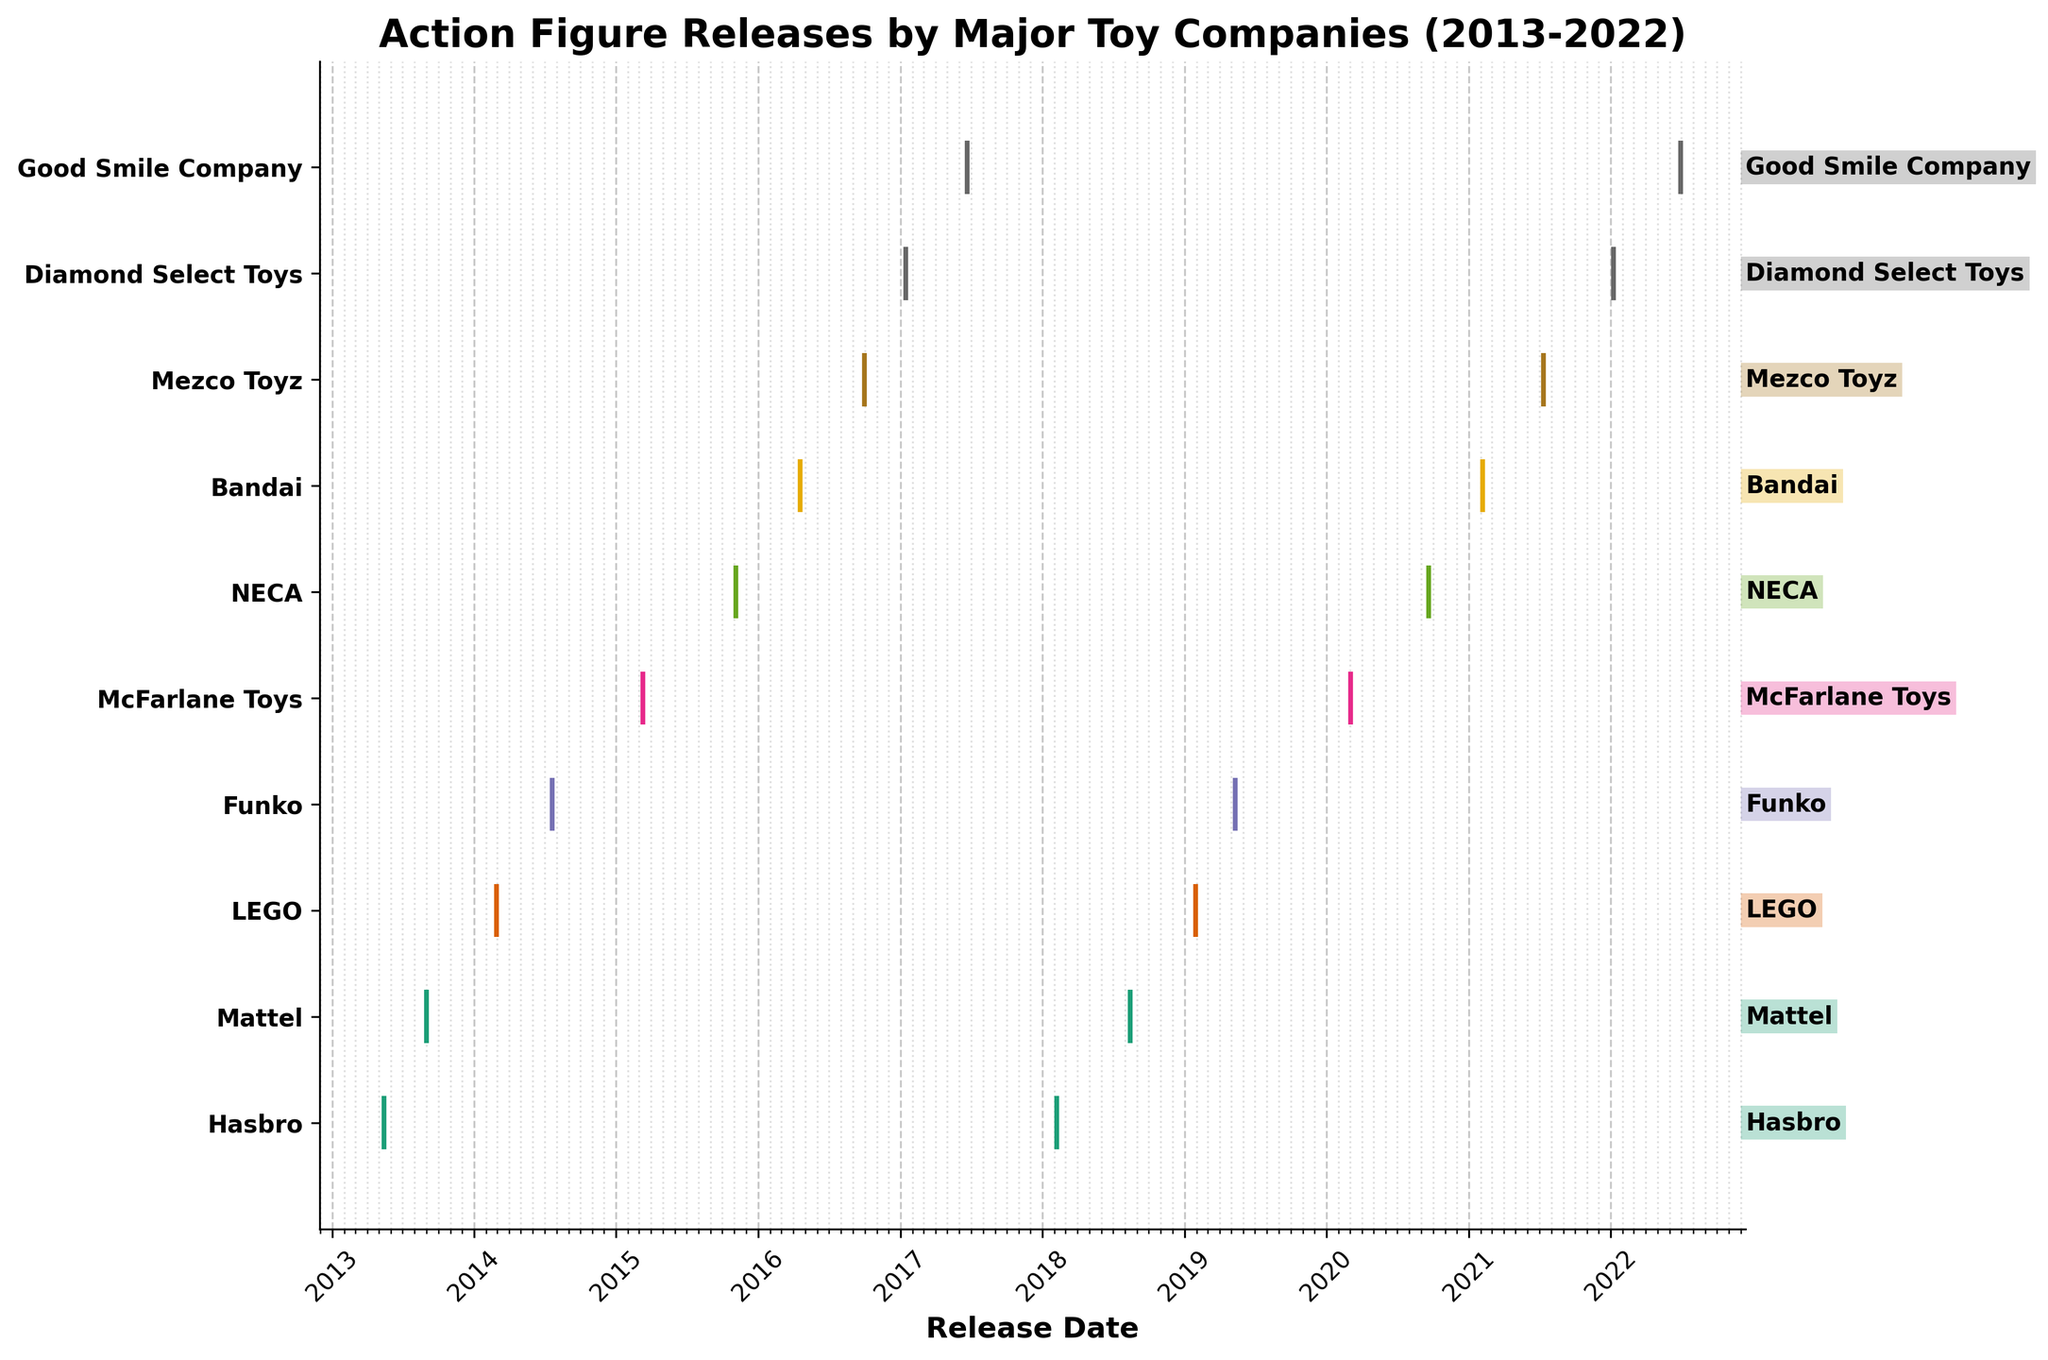what is the title of the plot? The title is located at the top of the plot, and it describes what the plot is about. It reads "Action Figure Releases by Major Toy Companies (2013-2022)".
Answer: Action Figure Releases by Major Toy Companies (2013-2022) what entity is on the y-axis between LEGO and Funko? By examining the y-axis labels, the company positioned between LEGO and Funko is clearly identified as Mattel.
Answer: Mattel how many release events does Hasbro have? To determine the number of release events for Hasbro, count the number of distinct vertical lines in the plot associated with the Hasbro label. There are two lines corresponding to Hasbro.
Answer: 2 which company had the first release in the timeline? The first event on the timeline, based on the horizontal position on the x-axis, belongs to Hasbro in 2013.
Answer: Hasbro how are the different companies distinguished in the plot? Different companies are distinguished by unique color coding for their respective events on the timeline.
Answer: by colors which company has the highest number of release events? Count the number of event lines for each company. The company with the highest count will have the most release events. Both Funko and Mattel have the highest count with three each.
Answer: Funko and Mattel which year had the most releases? To find out the year with the most entries, compare the density of vertical event lines year by year. 2017 and 2020 show the highest concentration of events.
Answer: 2017 and 2020 what is the longest gap between releases for any company? Identify the temporal distance between consecutive releases for each company by their line positions on the x-axis. The longest gap for any company is between Hasbro's releases from 2013 to 2018, a duration of about 5 years.
Answer: 5 years how often does Good Smile Company release new figures? Comparing the time intervals between Good Smile Company’s releases in 2017 and 2022, the interval is roughly five years.
Answer: about 5 years 